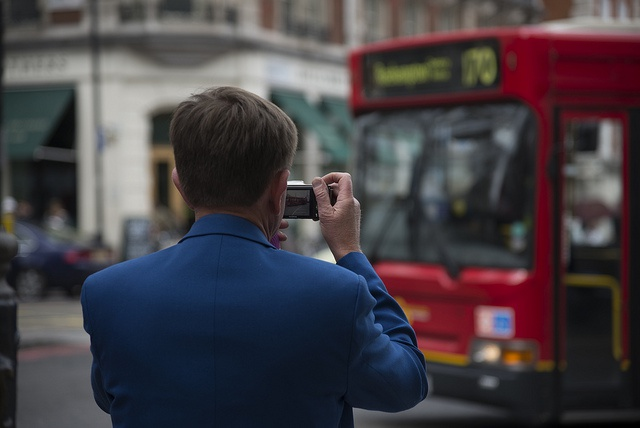Describe the objects in this image and their specific colors. I can see bus in black, maroon, gray, and darkgreen tones, people in black, navy, gray, and darkblue tones, car in black, gray, and olive tones, and cell phone in black, gray, darkgray, and lightgray tones in this image. 